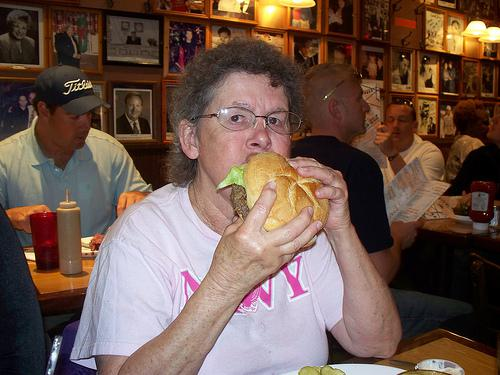Question: where was the photo taken?
Choices:
A. In a donut shop.
B. In a cafe.
C. In a cafeteria.
D. In a restaurant.
Answer with the letter. Answer: D Question: how is the photo?
Choices:
A. Clear.
B. Blurry.
C. Wet.
D. Faded.
Answer with the letter. Answer: A Question: what is the lady holding?
Choices:
A. A hotdog.
B. A burger.
C. A coke.
D. An ice cream sandwich.
Answer with the letter. Answer: B Question: who is in the photo?
Choices:
A. The woman.
B. Her mother.
C. People.
D. The husband.
Answer with the letter. Answer: C 